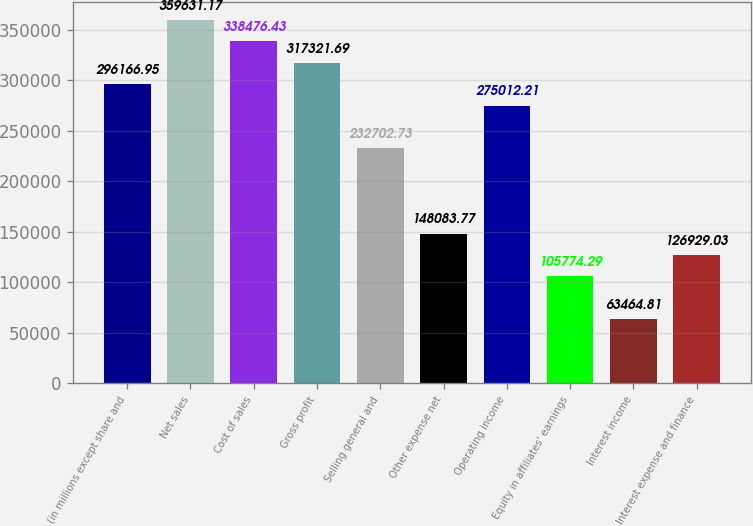Convert chart to OTSL. <chart><loc_0><loc_0><loc_500><loc_500><bar_chart><fcel>(in millions except share and<fcel>Net sales<fcel>Cost of sales<fcel>Gross profit<fcel>Selling general and<fcel>Other expense net<fcel>Operating income<fcel>Equity in affiliates' earnings<fcel>Interest income<fcel>Interest expense and finance<nl><fcel>296167<fcel>359631<fcel>338476<fcel>317322<fcel>232703<fcel>148084<fcel>275012<fcel>105774<fcel>63464.8<fcel>126929<nl></chart> 